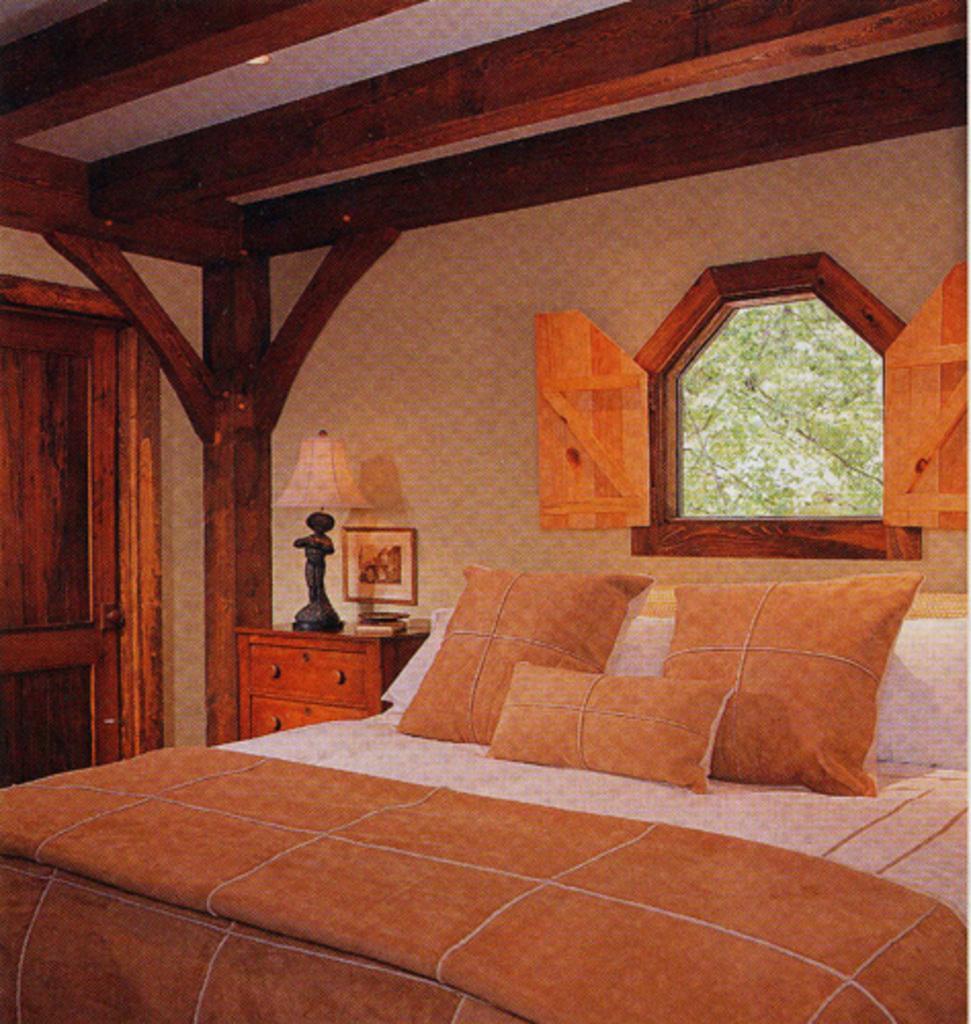Could you give a brief overview of what you see in this image? It is an inside view of the house. Here we can see bed with bed sheets, pillows. Background there is a wall, photo frame, lamp, wooden desk, door, pillar, window. 